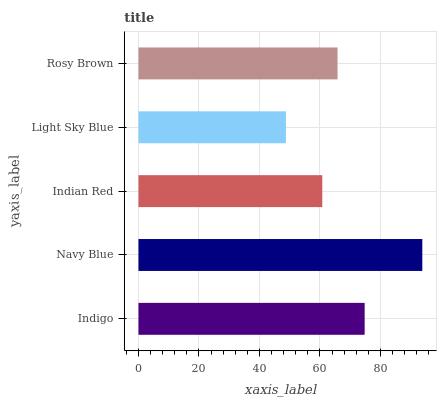Is Light Sky Blue the minimum?
Answer yes or no. Yes. Is Navy Blue the maximum?
Answer yes or no. Yes. Is Indian Red the minimum?
Answer yes or no. No. Is Indian Red the maximum?
Answer yes or no. No. Is Navy Blue greater than Indian Red?
Answer yes or no. Yes. Is Indian Red less than Navy Blue?
Answer yes or no. Yes. Is Indian Red greater than Navy Blue?
Answer yes or no. No. Is Navy Blue less than Indian Red?
Answer yes or no. No. Is Rosy Brown the high median?
Answer yes or no. Yes. Is Rosy Brown the low median?
Answer yes or no. Yes. Is Navy Blue the high median?
Answer yes or no. No. Is Navy Blue the low median?
Answer yes or no. No. 